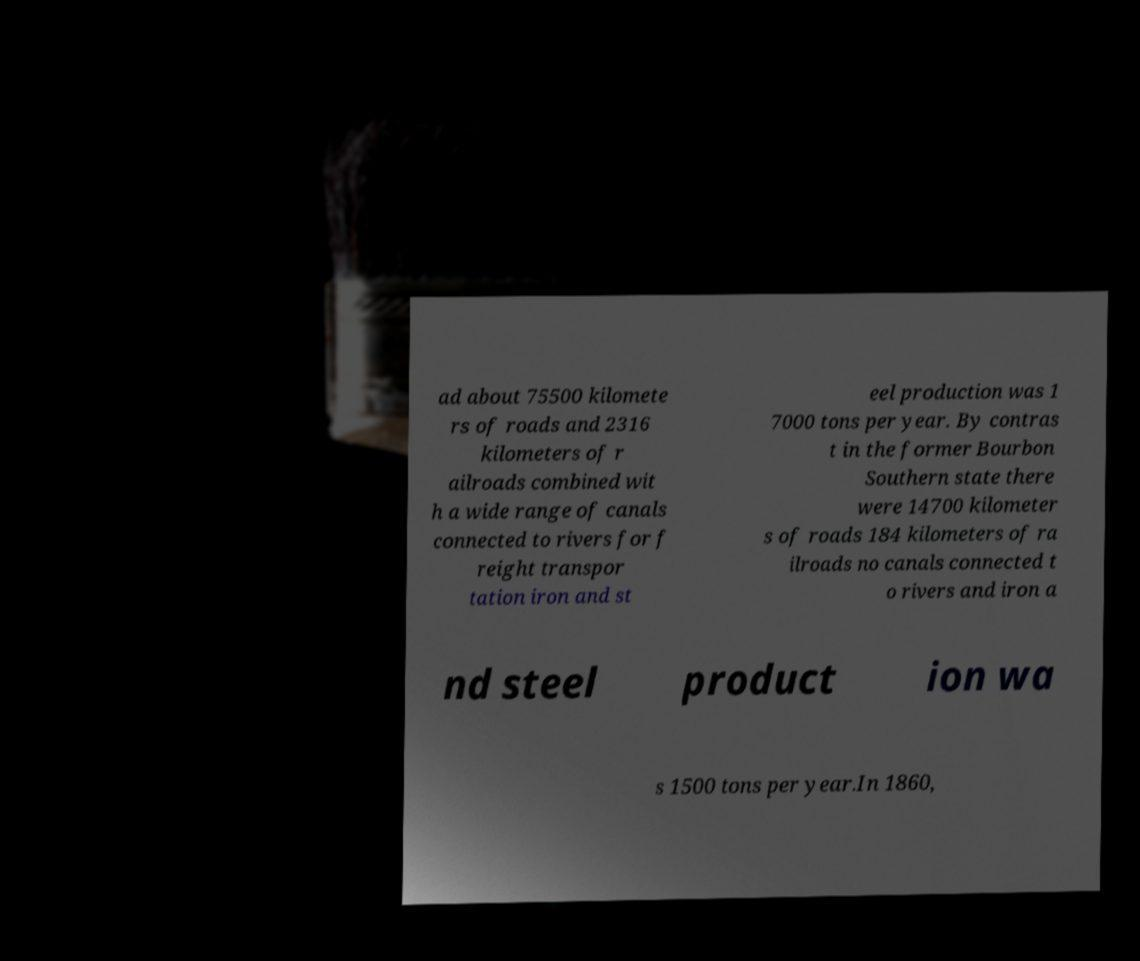What messages or text are displayed in this image? I need them in a readable, typed format. ad about 75500 kilomete rs of roads and 2316 kilometers of r ailroads combined wit h a wide range of canals connected to rivers for f reight transpor tation iron and st eel production was 1 7000 tons per year. By contras t in the former Bourbon Southern state there were 14700 kilometer s of roads 184 kilometers of ra ilroads no canals connected t o rivers and iron a nd steel product ion wa s 1500 tons per year.In 1860, 